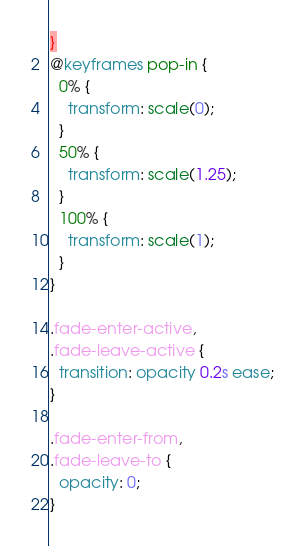Convert code to text. <code><loc_0><loc_0><loc_500><loc_500><_CSS_>}
@keyframes pop-in {
  0% {
    transform: scale(0);
  }
  50% {
    transform: scale(1.25);
  }
  100% {
    transform: scale(1);
  }
}

.fade-enter-active,
.fade-leave-active {
  transition: opacity 0.2s ease;
}

.fade-enter-from,
.fade-leave-to {
  opacity: 0;
}
</code> 